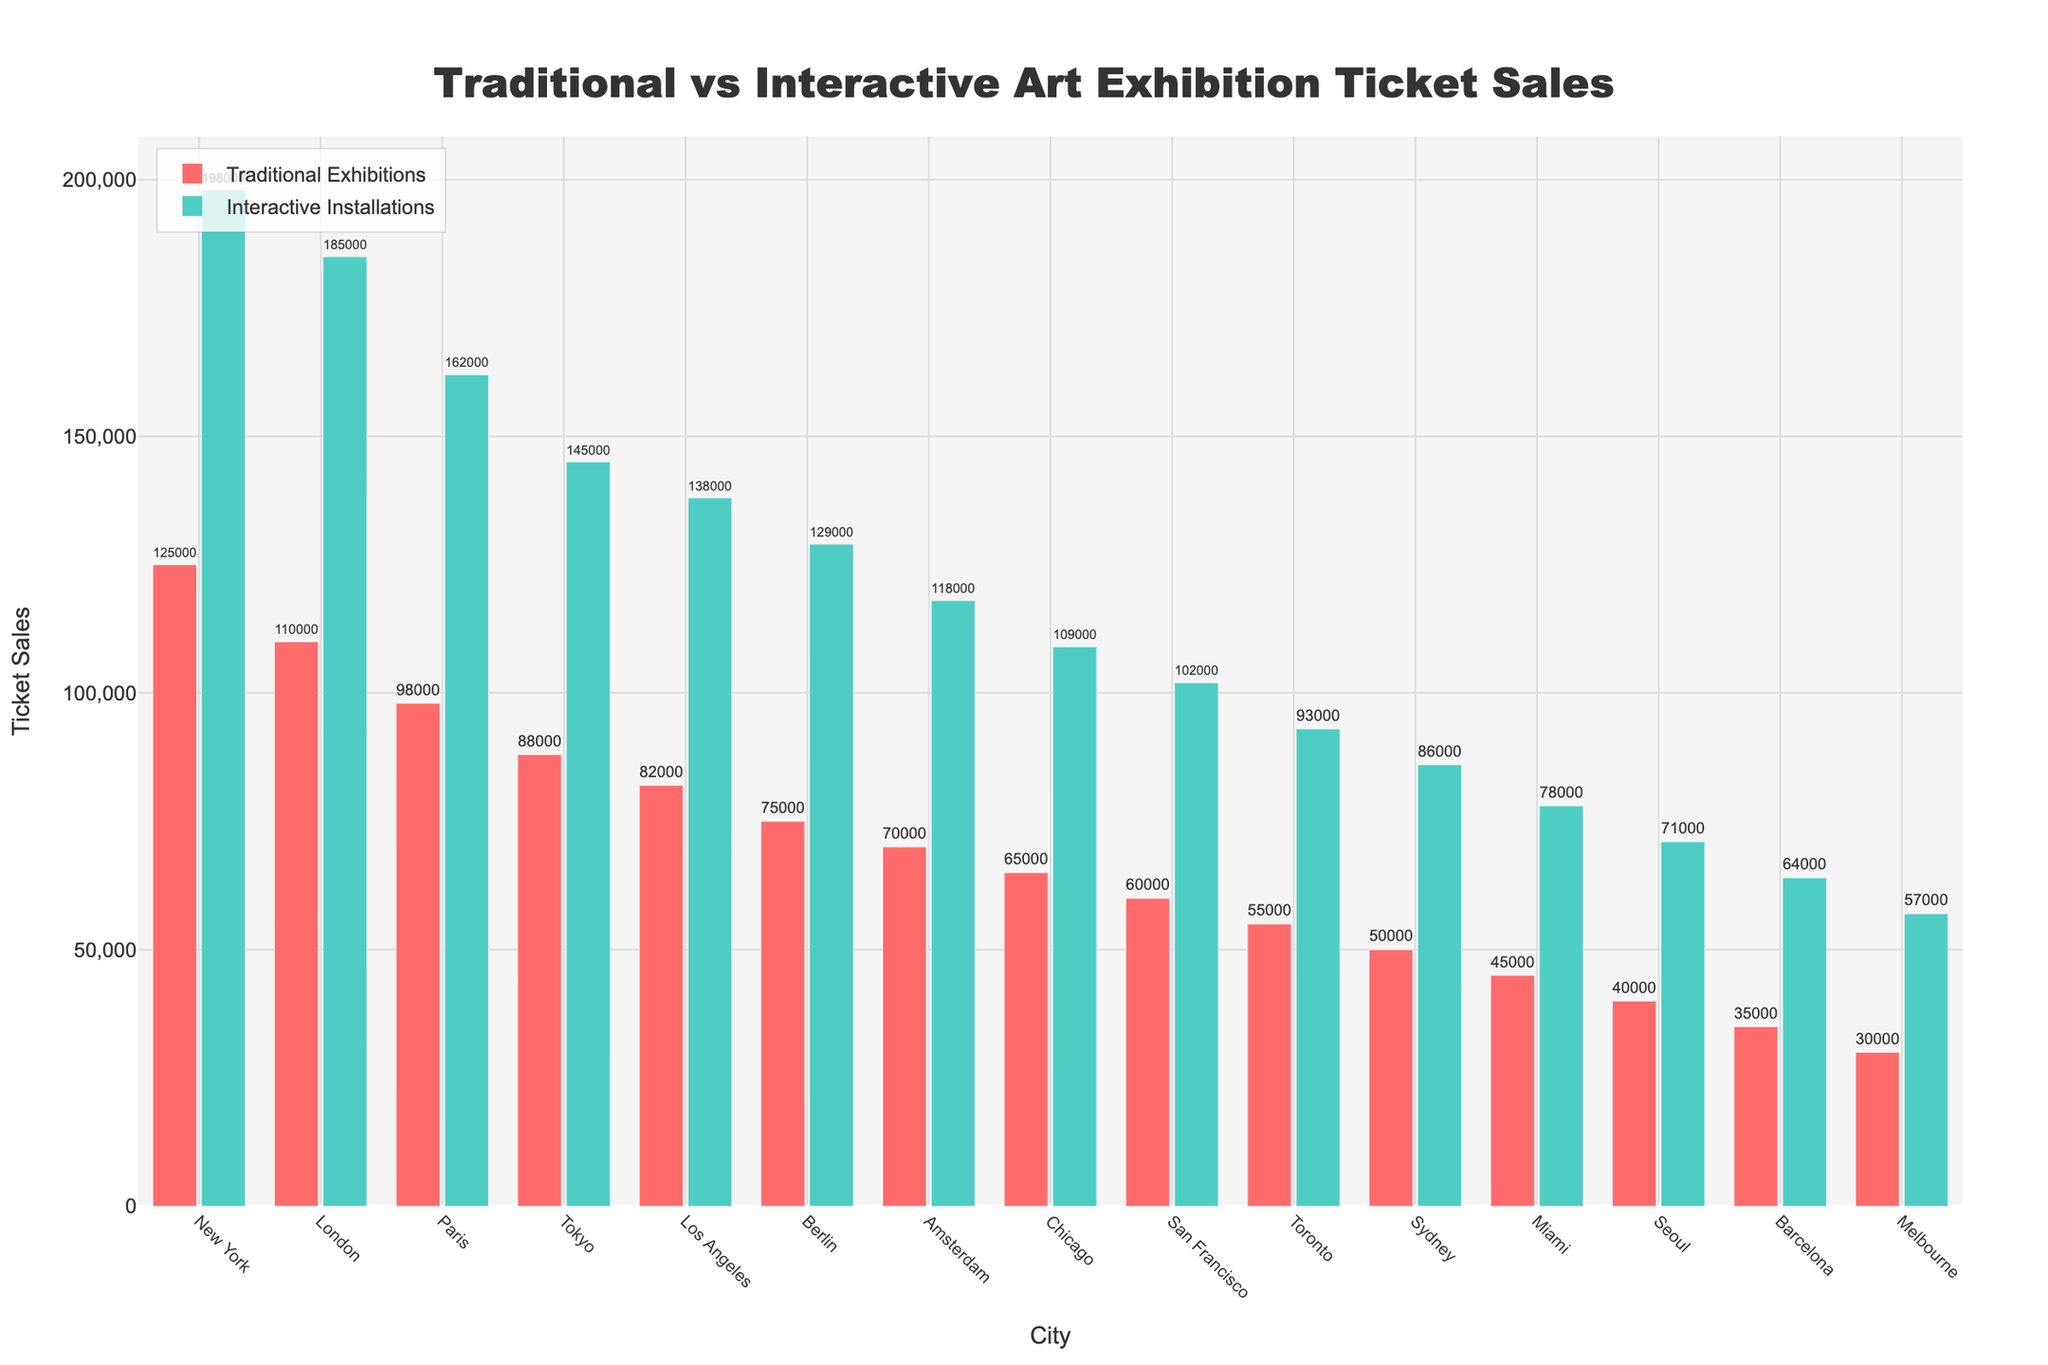What's the total number of ticket sales in New York? Sum the ticket sales of both traditional and interactive exhibitions in New York: 125,000 (Traditional) + 198,000 (Interactive) = 323,000
Answer: 323,000 Which city has the highest number of ticket sales for interactive installations? The highest bar for interactive installations is in New York with 198,000 sales
Answer: New York How do the ticket sales in Tokyo for traditional exhibitions compare with those in Berlin? The sales in Tokyo for traditional exhibitions are 88,000 while in Berlin it's 75,000. So, Tokyo has 13,000 more ticket sales
Answer: Tokyo Where are the ticket sales for traditional exhibitions higher - in Barcelona or Melbourne? Barcelona's traditional exhibition sales are 35,000 compared to Melbourne's 30,000. Barcelona has higher sales
Answer: Barcelona What's the difference between ticket sales for interactive installations in London and Paris? The ticket sales for interactive installations in London are 185,000, and in Paris, it's 162,000. The difference is 185,000 - 162,000 = 23,000
Answer: 23,000 Which city has the smallest difference between traditional and interactive ticket sales? By calculating differences for each city, Seoul has the smallest difference: 71,000 (Interactive) - 40,000 (Traditional) = 31,000
Answer: Seoul How much higher are ticket sales for interactive installations than traditional exhibitions in Los Angeles? Interactive installations in Los Angeles have 138,000 sales while traditional exhibitions have 82,000. The difference is 138,000 - 82,000 = 56,000
Answer: 56,000 In which city is the gap between ticket sales for traditional and interactive exhibitions the largest? New York has the largest gap. Interactive sales are 198,000, and traditional sales are 125,000, making the gap 198,000 - 125,000 = 73,000
Answer: New York Which city has lower ticket sales for interactive installations, San Francisco or Toronto? San Francisco has 102,000 for interactive installations while Toronto has 93,000. Therefore, Toronto has lower sales
Answer: Toronto 